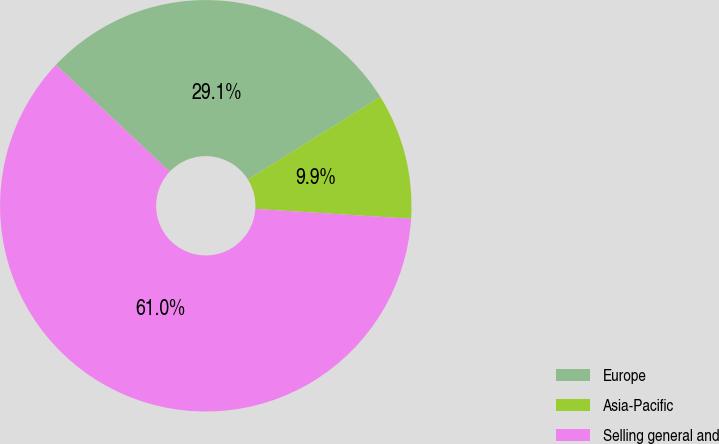Convert chart to OTSL. <chart><loc_0><loc_0><loc_500><loc_500><pie_chart><fcel>Europe<fcel>Asia-Pacific<fcel>Selling general and<nl><fcel>29.11%<fcel>9.88%<fcel>61.01%<nl></chart> 